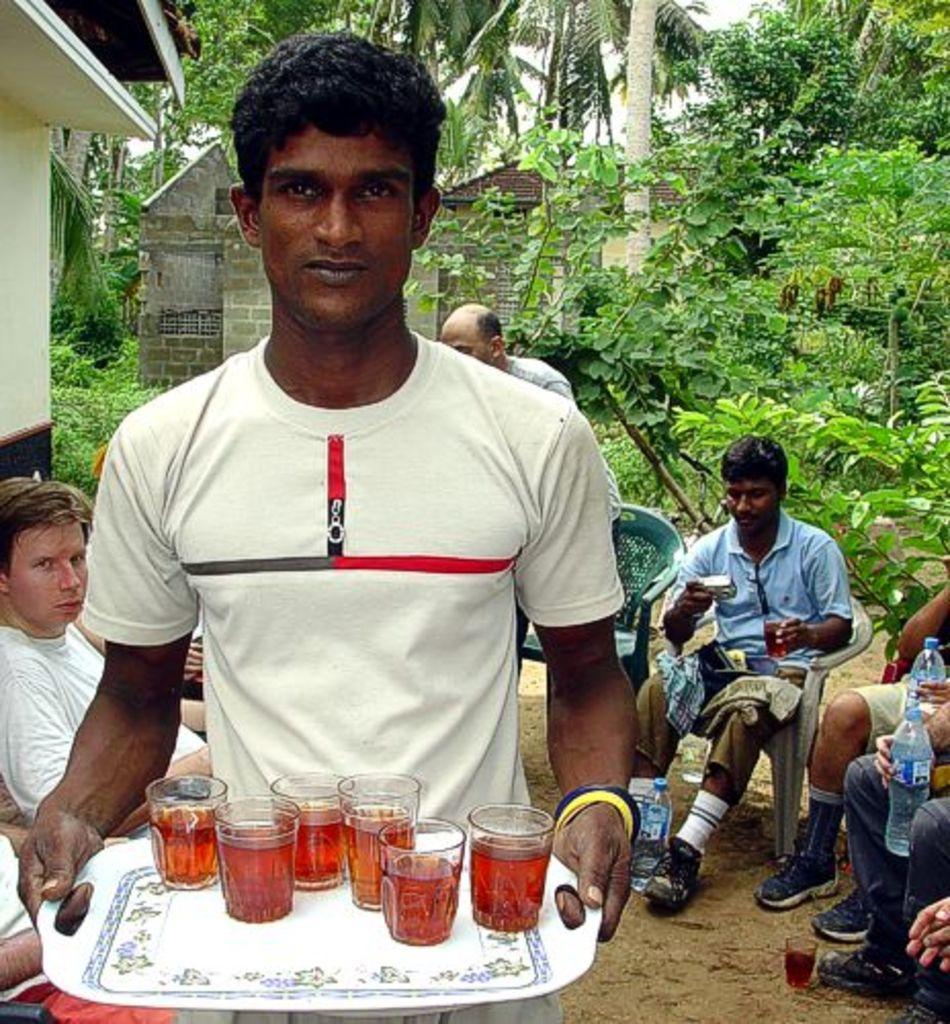Could you give a brief overview of what you see in this image? In this image in the foreground there is one person standing and he is holding a tray, in the tray there are some glasses. And in the glasses there is drink and in the background there are some people sitting on chairs and they are holding bottles and glasses, and objects and also we could see trees and houses. At the bottom there is sand. 